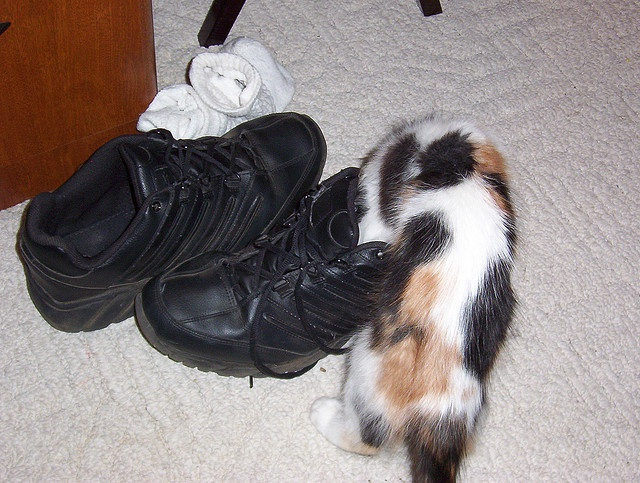Describe the objects in this image and their specific colors. I can see a cat in maroon, lightgray, black, darkgray, and gray tones in this image. 